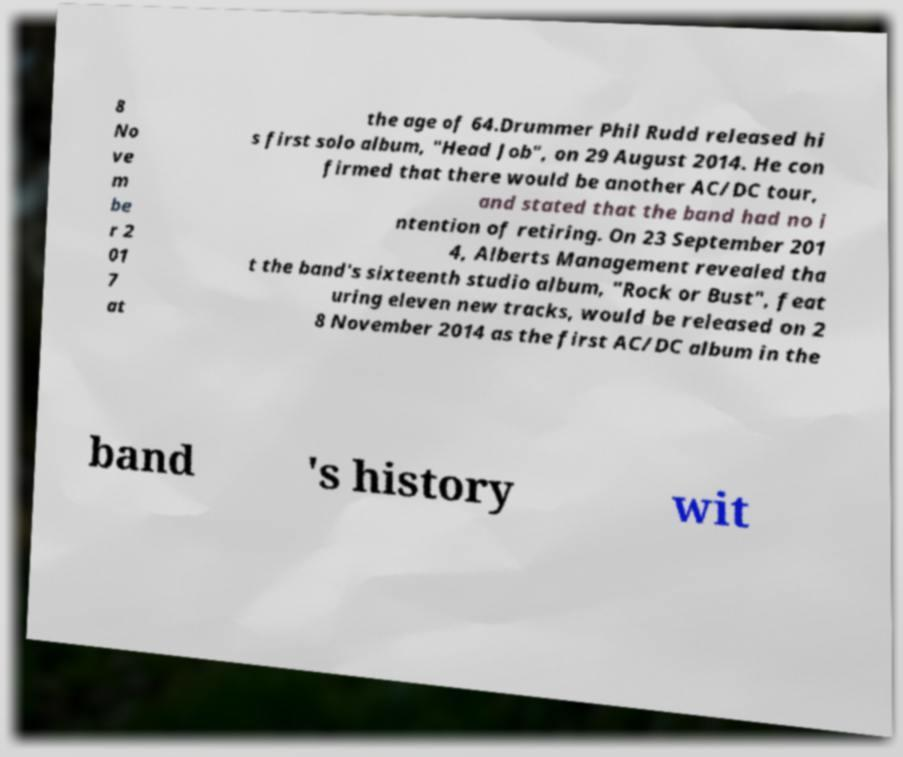Can you read and provide the text displayed in the image?This photo seems to have some interesting text. Can you extract and type it out for me? 8 No ve m be r 2 01 7 at the age of 64.Drummer Phil Rudd released hi s first solo album, "Head Job", on 29 August 2014. He con firmed that there would be another AC/DC tour, and stated that the band had no i ntention of retiring. On 23 September 201 4, Alberts Management revealed tha t the band's sixteenth studio album, "Rock or Bust", feat uring eleven new tracks, would be released on 2 8 November 2014 as the first AC/DC album in the band 's history wit 